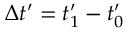Convert formula to latex. <formula><loc_0><loc_0><loc_500><loc_500>\Delta t ^ { \prime } = t _ { 1 } ^ { \prime } - t _ { 0 } ^ { \prime }</formula> 